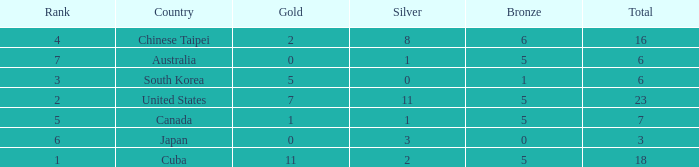What was the sum of the ranks for Japan who had less than 5 bronze medals and more than 3 silvers? None. 